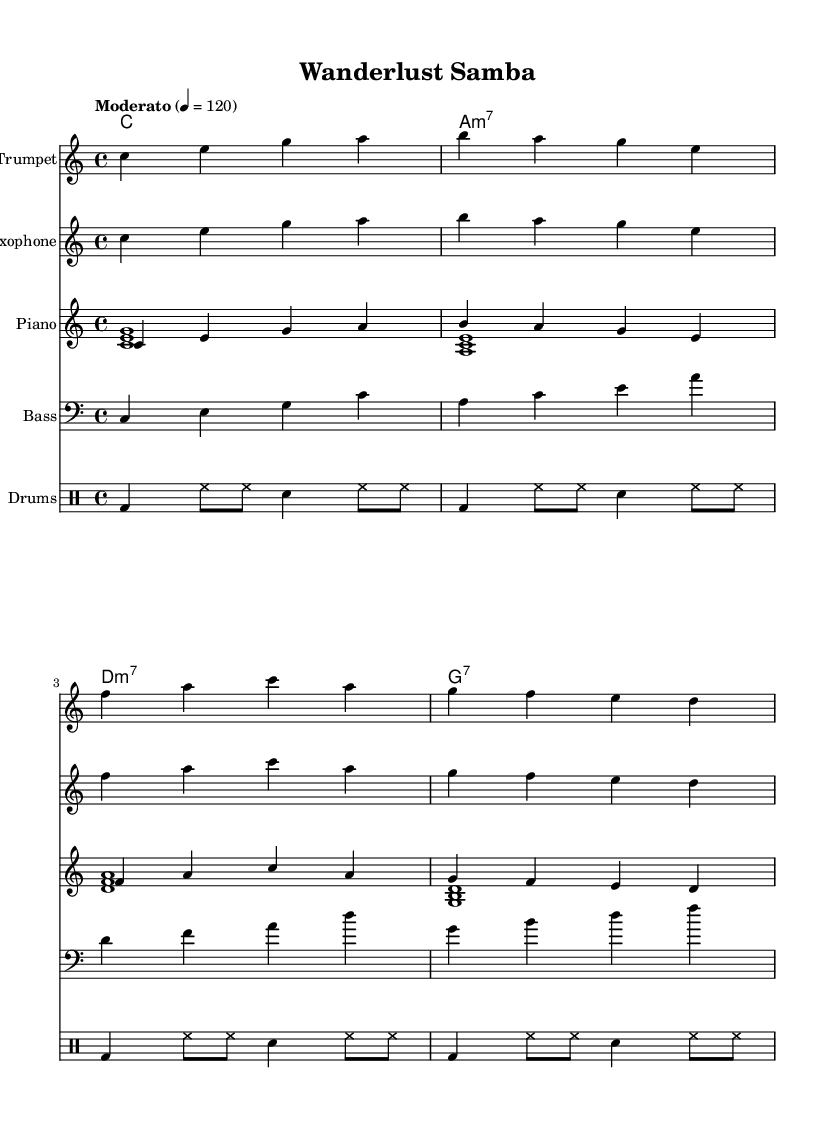What is the key signature of this music? The key signature indicated in the score is C major, which is represented by no sharps or flats.
Answer: C major What is the time signature of this piece? The time signature is 4/4, which means there are four beats in each measure, and the quarter note gets one beat.
Answer: 4/4 What is the tempo marking for this piece? The tempo marking is "Moderato," which suggests a moderate speed, specifically noted as quarter note equals 120 beats per minute.
Answer: Moderato How many measures are there in the Trumpet part? By counting the measures, it can be seen that there are a total of four measures in the Trumpet part.
Answer: Four Which instruments are featured in this composition? The instruments listed in the score are Trumpet, Saxophone, Piano, Bass, and Drums.
Answer: Trumpet, Saxophone, Piano, Bass, Drums What is the rhythmic pattern for the drums? The rhythmic pattern for the drums consists of bass drum hits on the first beat, hi-hat play throughout, and snare hits on the third beat in each measure, repeating every four measures.
Answer: Bass and snare pattern How do the chords change in this piece? The chords change according to the following sequence: C major, A minor 7, D minor 7, and G7, which sets up a common jazz progression.
Answer: C, A minor 7, D minor 7, G7 